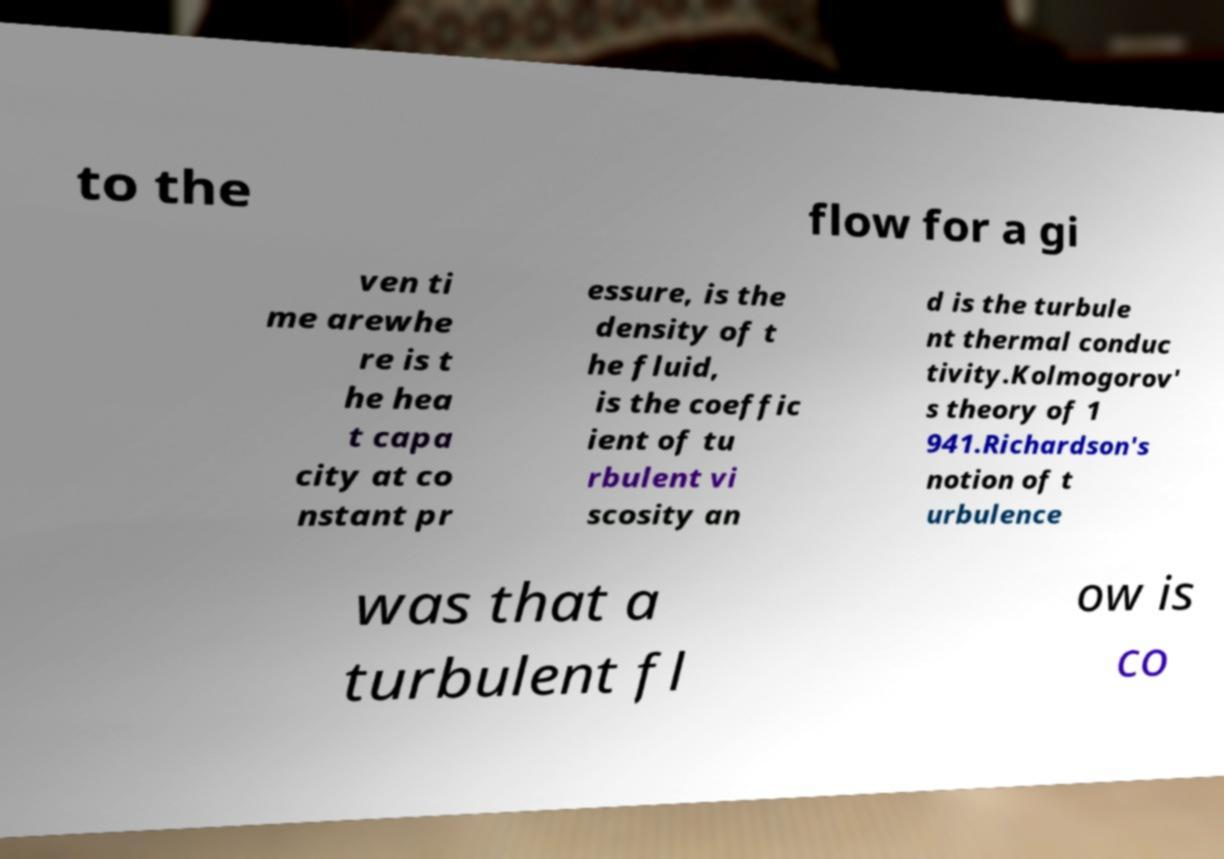I need the written content from this picture converted into text. Can you do that? to the flow for a gi ven ti me arewhe re is t he hea t capa city at co nstant pr essure, is the density of t he fluid, is the coeffic ient of tu rbulent vi scosity an d is the turbule nt thermal conduc tivity.Kolmogorov' s theory of 1 941.Richardson's notion of t urbulence was that a turbulent fl ow is co 